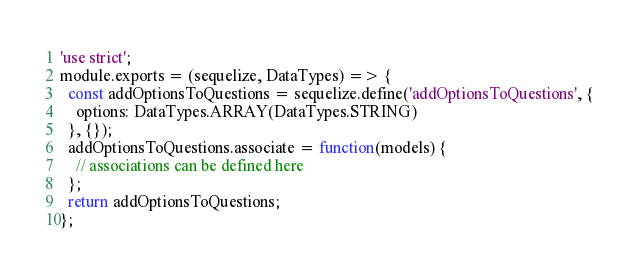<code> <loc_0><loc_0><loc_500><loc_500><_JavaScript_>'use strict';
module.exports = (sequelize, DataTypes) => {
  const addOptionsToQuestions = sequelize.define('addOptionsToQuestions', {
    options: DataTypes.ARRAY(DataTypes.STRING)
  }, {});
  addOptionsToQuestions.associate = function(models) {
    // associations can be defined here
  };
  return addOptionsToQuestions;
};</code> 